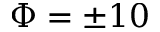<formula> <loc_0><loc_0><loc_500><loc_500>\Phi = \pm 1 0</formula> 